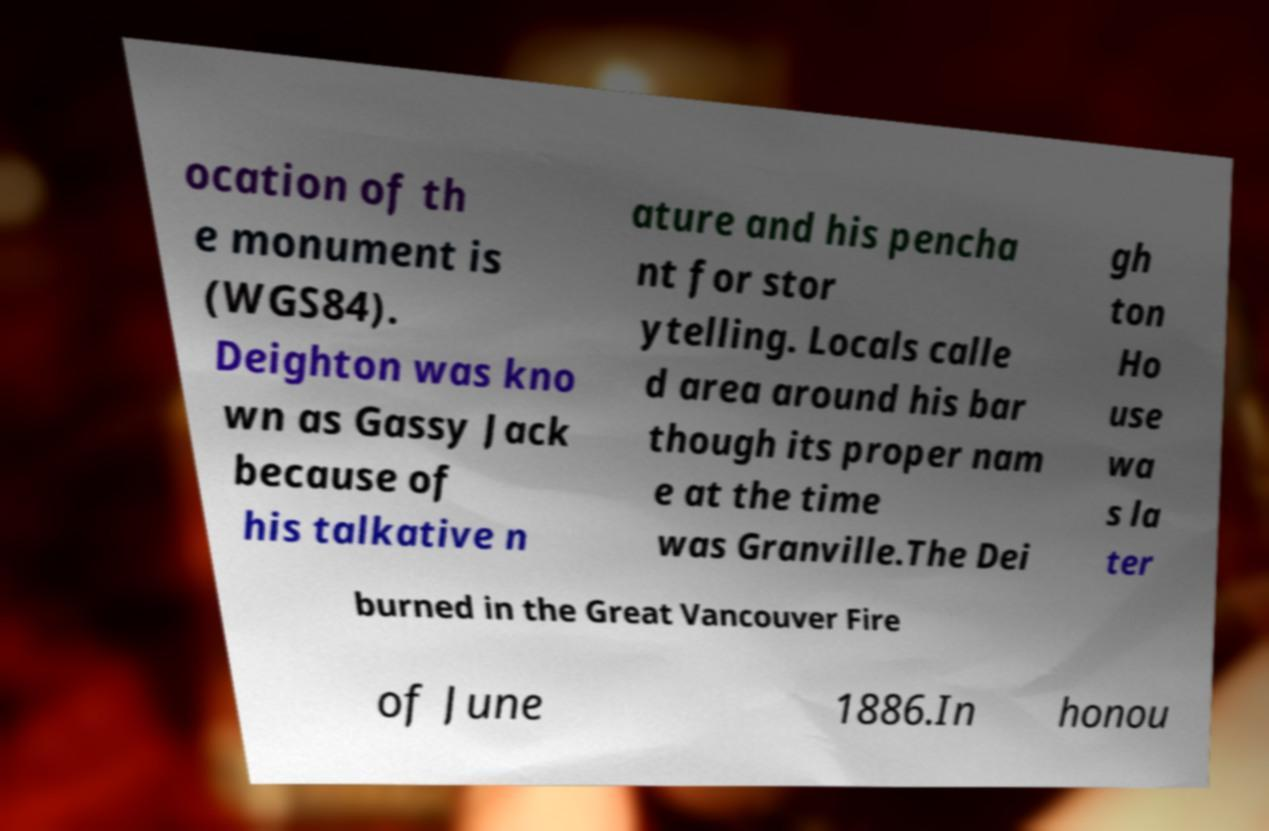Can you read and provide the text displayed in the image?This photo seems to have some interesting text. Can you extract and type it out for me? ocation of th e monument is (WGS84). Deighton was kno wn as Gassy Jack because of his talkative n ature and his pencha nt for stor ytelling. Locals calle d area around his bar though its proper nam e at the time was Granville.The Dei gh ton Ho use wa s la ter burned in the Great Vancouver Fire of June 1886.In honou 